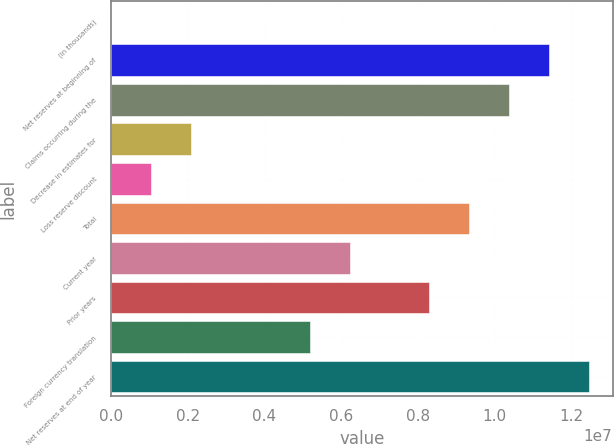<chart> <loc_0><loc_0><loc_500><loc_500><bar_chart><fcel>(In thousands)<fcel>Net reserves at beginning of<fcel>Claims occurring during the<fcel>Decrease in estimates for<fcel>Loss reserve discount<fcel>Total<fcel>Current year<fcel>Prior years<fcel>Foreign currency translation<fcel>Net reserves at end of year<nl><fcel>2014<fcel>1.14065e+07<fcel>1.03697e+07<fcel>2.07555e+06<fcel>1.03878e+06<fcel>9.33293e+06<fcel>6.22263e+06<fcel>8.29616e+06<fcel>5.18586e+06<fcel>1.24432e+07<nl></chart> 